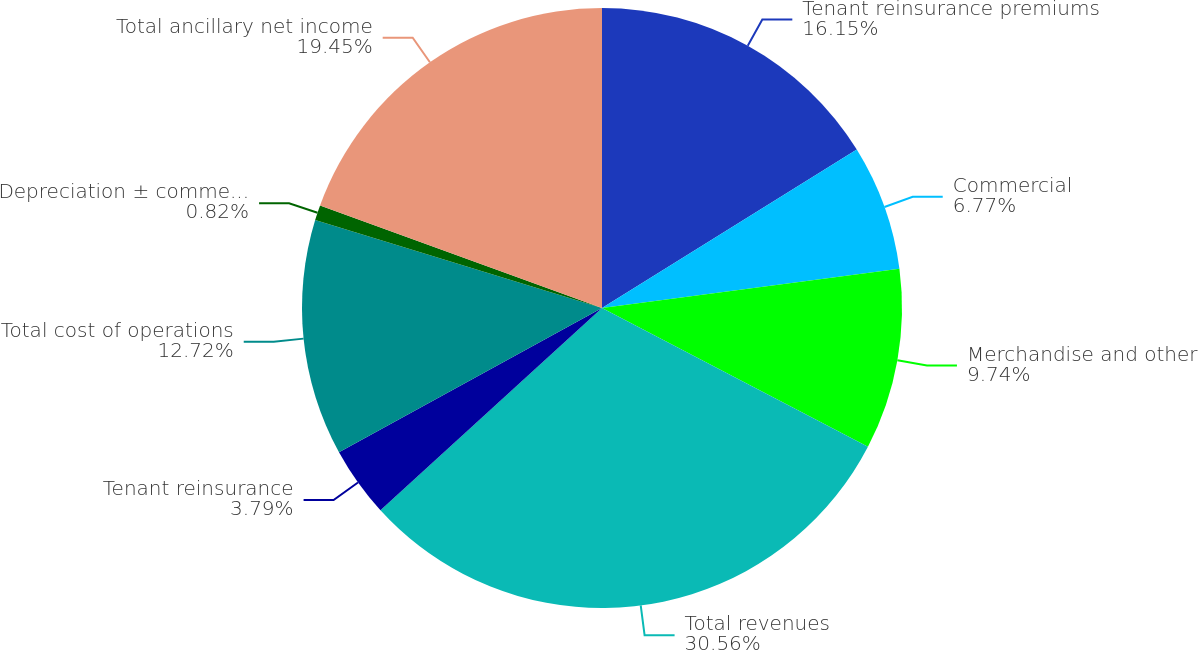<chart> <loc_0><loc_0><loc_500><loc_500><pie_chart><fcel>Tenant reinsurance premiums<fcel>Commercial<fcel>Merchandise and other<fcel>Total revenues<fcel>Tenant reinsurance<fcel>Total cost of operations<fcel>Depreciation ± commercial<fcel>Total ancillary net income<nl><fcel>16.15%<fcel>6.77%<fcel>9.74%<fcel>30.57%<fcel>3.79%<fcel>12.72%<fcel>0.82%<fcel>19.45%<nl></chart> 